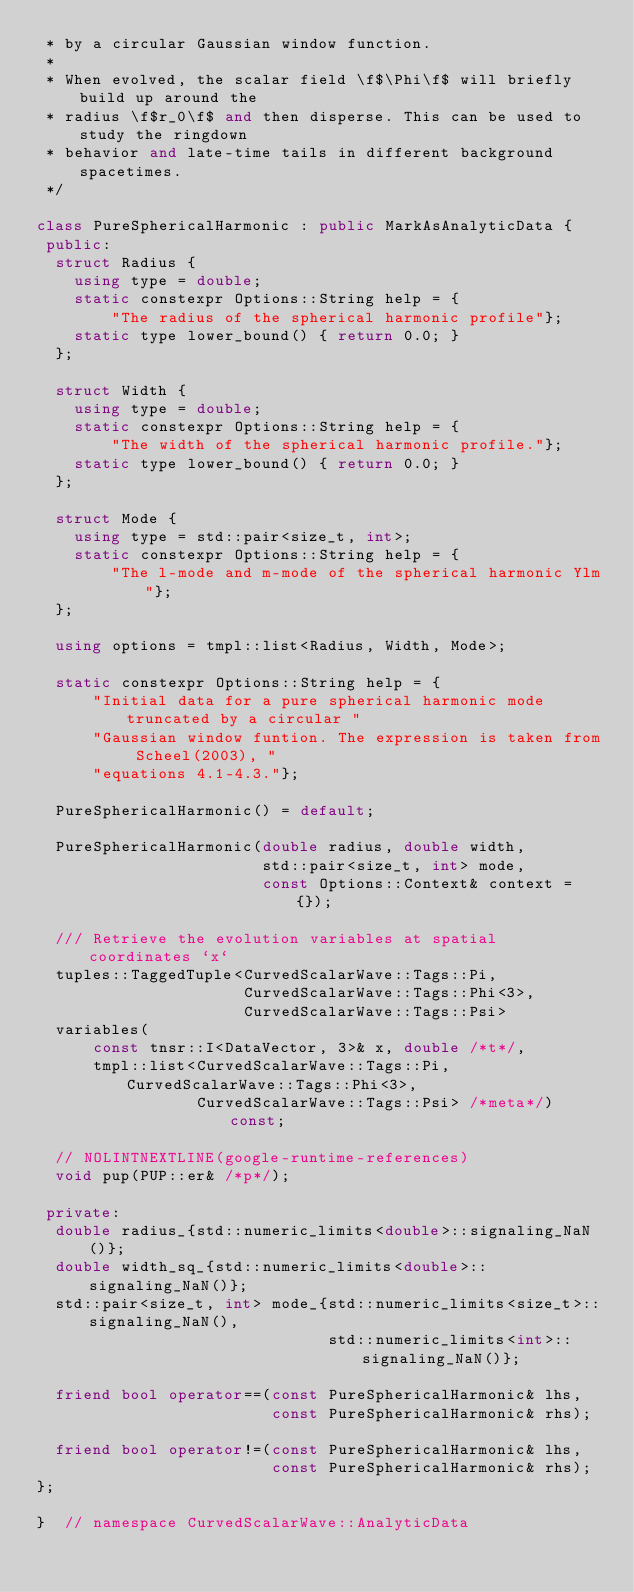<code> <loc_0><loc_0><loc_500><loc_500><_C++_> * by a circular Gaussian window function.
 *
 * When evolved, the scalar field \f$\Phi\f$ will briefly build up around the
 * radius \f$r_0\f$ and then disperse. This can be used to study the ringdown
 * behavior and late-time tails in different background spacetimes.
 */

class PureSphericalHarmonic : public MarkAsAnalyticData {
 public:
  struct Radius {
    using type = double;
    static constexpr Options::String help = {
        "The radius of the spherical harmonic profile"};
    static type lower_bound() { return 0.0; }
  };

  struct Width {
    using type = double;
    static constexpr Options::String help = {
        "The width of the spherical harmonic profile."};
    static type lower_bound() { return 0.0; }
  };

  struct Mode {
    using type = std::pair<size_t, int>;
    static constexpr Options::String help = {
        "The l-mode and m-mode of the spherical harmonic Ylm"};
  };

  using options = tmpl::list<Radius, Width, Mode>;

  static constexpr Options::String help = {
      "Initial data for a pure spherical harmonic mode truncated by a circular "
      "Gaussian window funtion. The expression is taken from Scheel(2003), "
      "equations 4.1-4.3."};

  PureSphericalHarmonic() = default;

  PureSphericalHarmonic(double radius, double width,
                        std::pair<size_t, int> mode,
                        const Options::Context& context = {});

  /// Retrieve the evolution variables at spatial coordinates `x`
  tuples::TaggedTuple<CurvedScalarWave::Tags::Pi,
                      CurvedScalarWave::Tags::Phi<3>,
                      CurvedScalarWave::Tags::Psi>
  variables(
      const tnsr::I<DataVector, 3>& x, double /*t*/,
      tmpl::list<CurvedScalarWave::Tags::Pi, CurvedScalarWave::Tags::Phi<3>,
                 CurvedScalarWave::Tags::Psi> /*meta*/) const;

  // NOLINTNEXTLINE(google-runtime-references)
  void pup(PUP::er& /*p*/);

 private:
  double radius_{std::numeric_limits<double>::signaling_NaN()};
  double width_sq_{std::numeric_limits<double>::signaling_NaN()};
  std::pair<size_t, int> mode_{std::numeric_limits<size_t>::signaling_NaN(),
                               std::numeric_limits<int>::signaling_NaN()};

  friend bool operator==(const PureSphericalHarmonic& lhs,
                         const PureSphericalHarmonic& rhs);

  friend bool operator!=(const PureSphericalHarmonic& lhs,
                         const PureSphericalHarmonic& rhs);
};

}  // namespace CurvedScalarWave::AnalyticData
</code> 